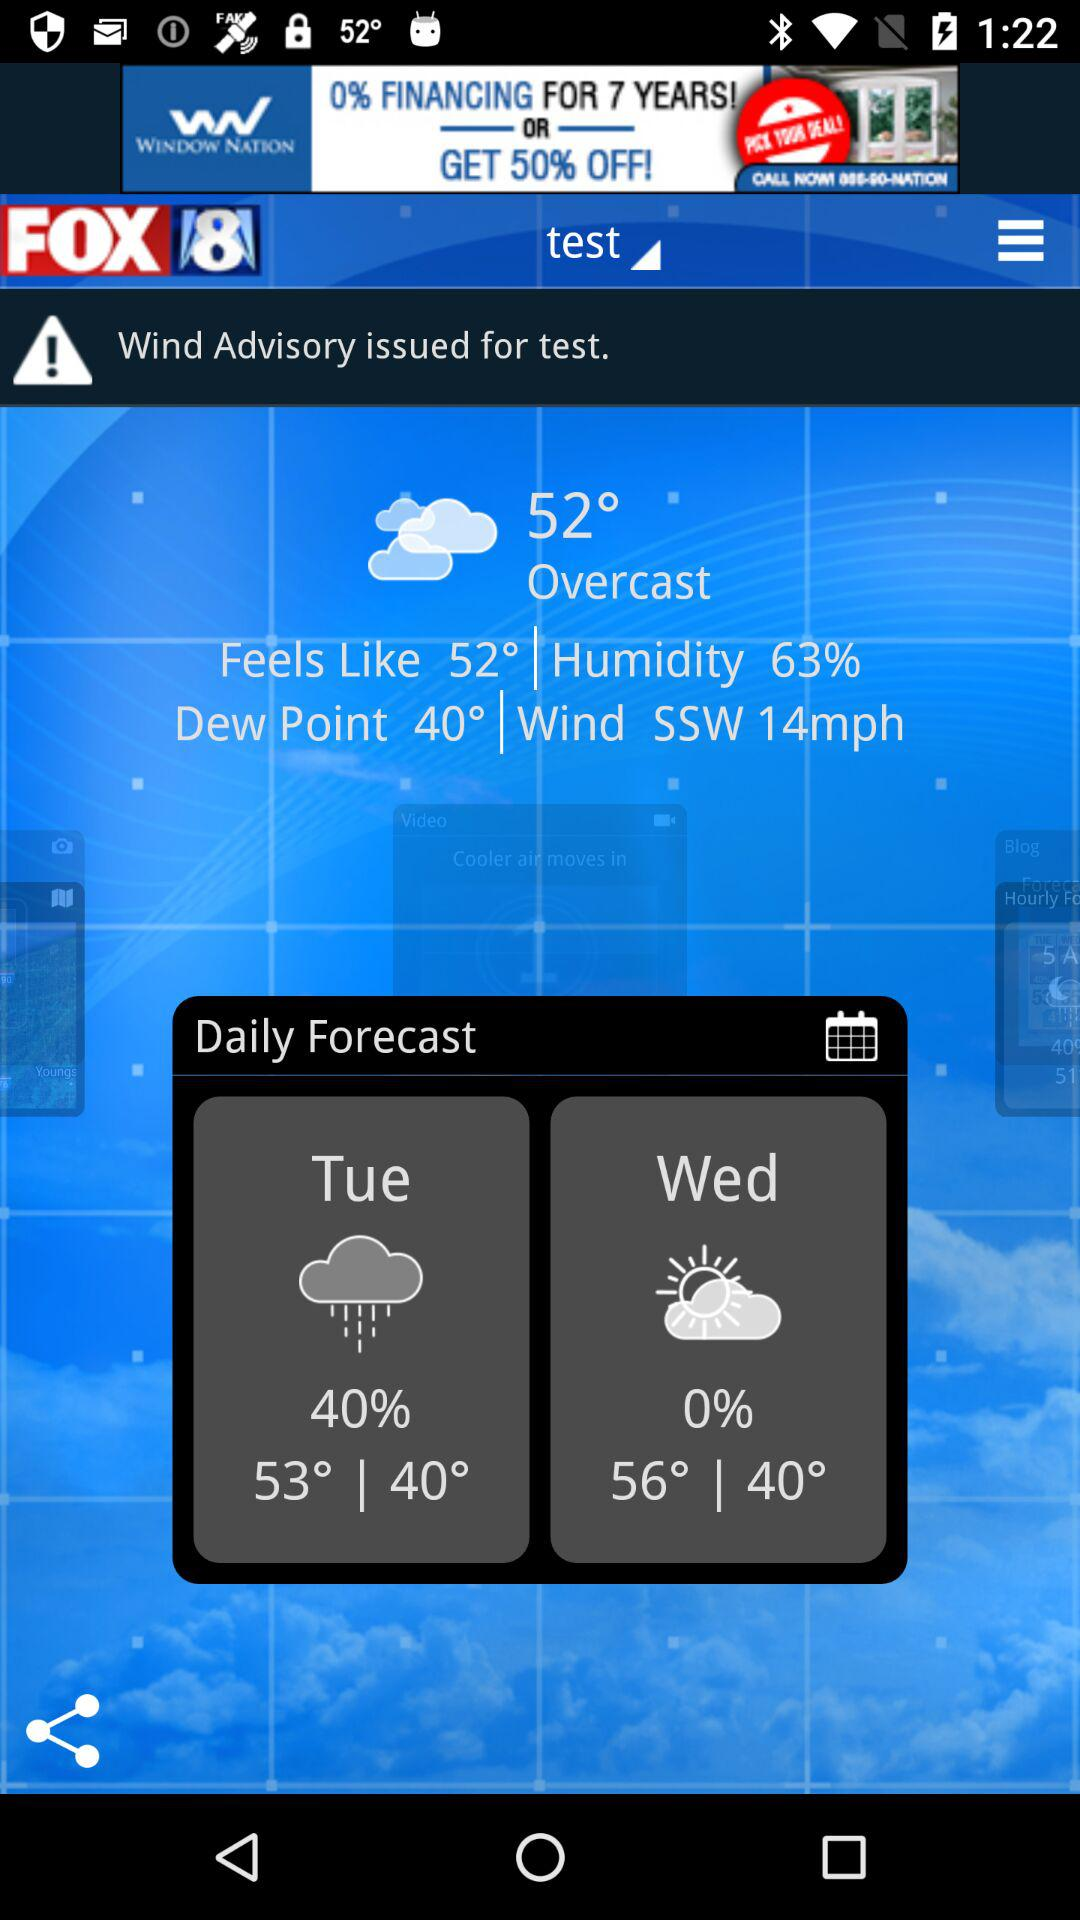How many days are in the forecast?
Answer the question using a single word or phrase. 2 